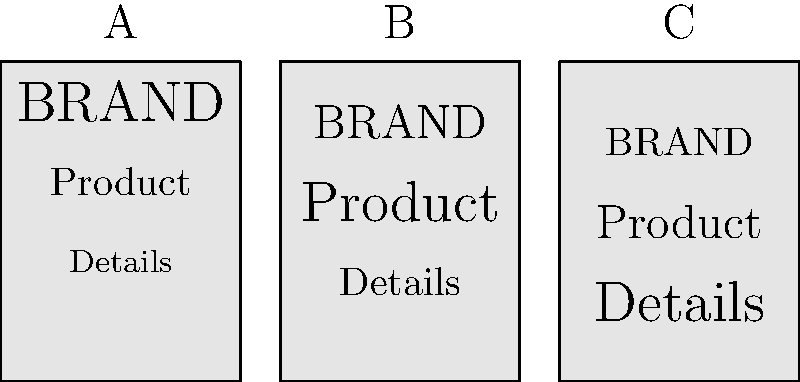As a minimalist packaging designer, which of the above typographic hierarchies (A, B, or C) would you consider most effective for emphasizing the product name while maintaining a clean, minimalist aesthetic? To determine the most effective typographic hierarchy for minimalist packaging that emphasizes the product name, let's analyze each option:

1. Option A:
   - BRAND: Largest font size
   - Product: Medium font size
   - Details: Smallest font size
   This hierarchy emphasizes the brand name over the product name.

2. Option B:
   - BRAND: Medium font size
   - Product: Largest font size
   - Details: Smallest font size
   This hierarchy emphasizes the product name, giving it the most visual weight.

3. Option C:
   - BRAND: Smallest font size
   - Product: Medium font size
   - Details: Largest font size
   This hierarchy emphasizes the details, which is not typical for minimalist packaging.

For minimalist packaging that emphasizes the product name:
1. The product name should have the largest font size to draw attention.
2. The brand name should be visible but not overshadow the product name.
3. Details should have the smallest font size to maintain a clean look.

Option B best meets these criteria by giving the product name the most prominence while maintaining a clear hierarchy and minimalist aesthetic.
Answer: B 